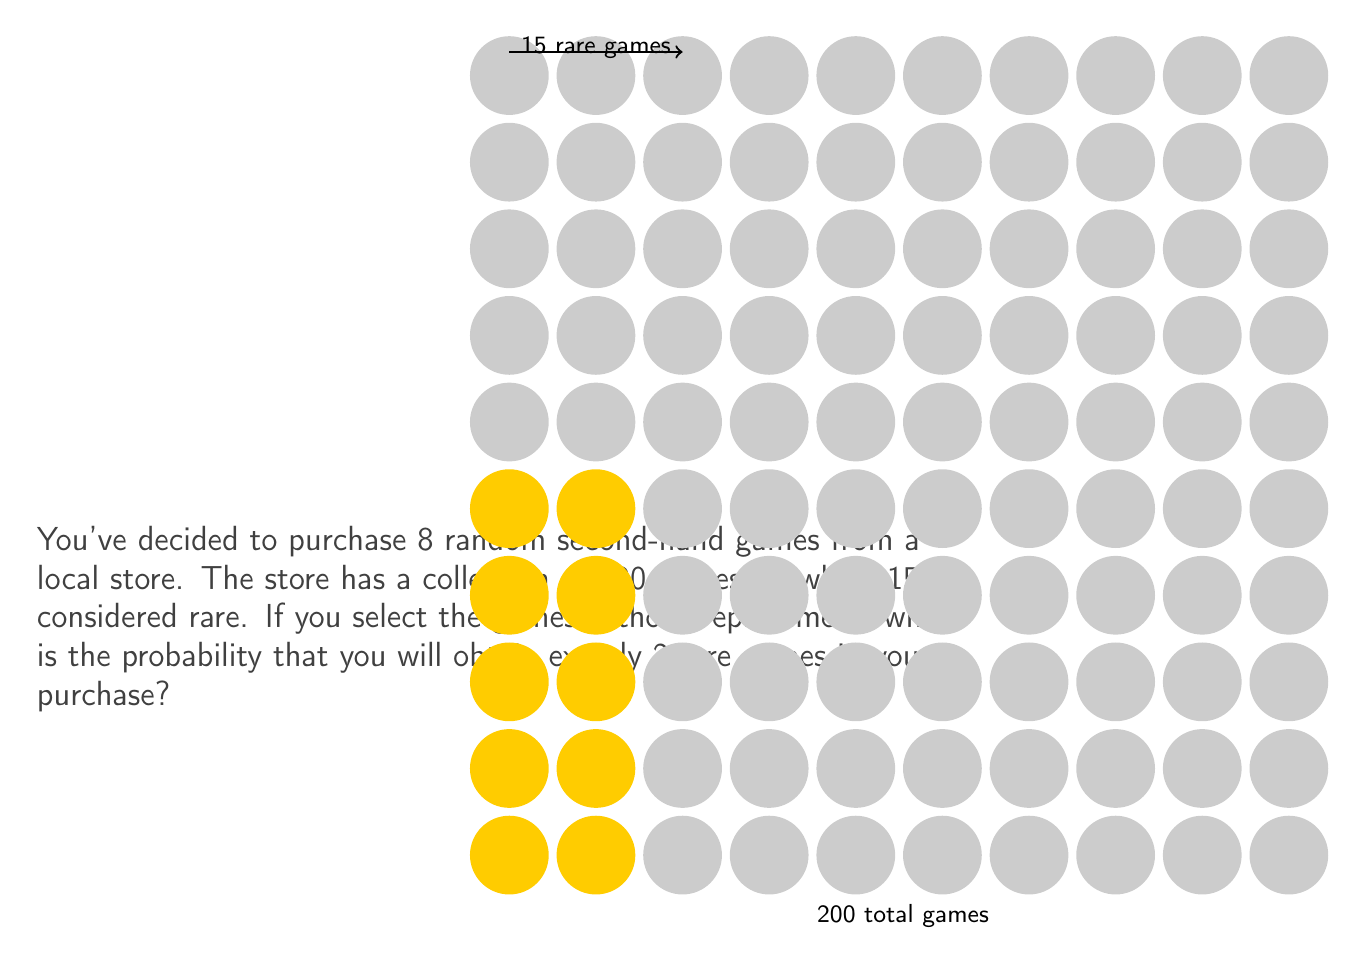Can you answer this question? Let's approach this step-by-step using the hypergeometric distribution:

1) We are dealing with a hypergeometric distribution because:
   - We are sampling without replacement
   - Each game is either rare or not rare
   - We're interested in the exact number of successes (rare games)

2) The probability mass function for the hypergeometric distribution is:

   $$P(X = k) = \frac{\binom{K}{k} \binom{N-K}{n-k}}{\binom{N}{n}}$$

   Where:
   $N$ = total number of games = 200
   $K$ = number of rare games = 15
   $n$ = number of games purchased = 8
   $k$ = number of rare games we want = 2

3) Let's substitute these values:

   $$P(X = 2) = \frac{\binom{15}{2} \binom{200-15}{8-2}}{\binom{200}{8}}$$

4) Calculate each combination:
   $\binom{15}{2} = 105$
   $\binom{185}{6} = 27,907,600$
   $\binom{200}{8} = 125,970,240$

5) Substitute these values:

   $$P(X = 2) = \frac{105 \times 27,907,600}{125,970,240}$$

6) Simplify:

   $$P(X = 2) = \frac{2,930,298,000}{125,970,240} \approx 0.2326$$

Therefore, the probability of obtaining exactly 2 rare games out of 8 random purchases is approximately 0.2326 or 23.26%.
Answer: $\frac{2,930,298,000}{125,970,240} \approx 0.2326$ 